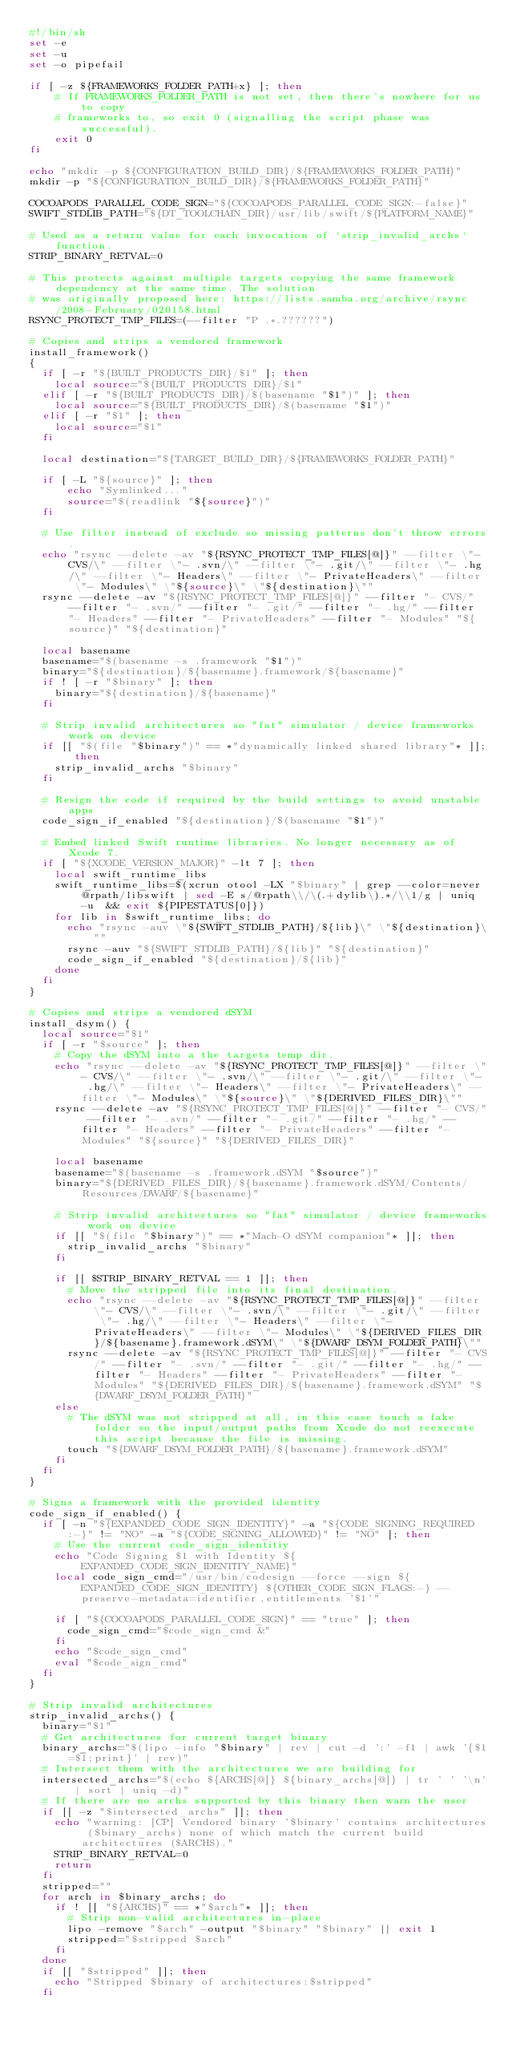<code> <loc_0><loc_0><loc_500><loc_500><_Bash_>#!/bin/sh
set -e
set -u
set -o pipefail

if [ -z ${FRAMEWORKS_FOLDER_PATH+x} ]; then
    # If FRAMEWORKS_FOLDER_PATH is not set, then there's nowhere for us to copy
    # frameworks to, so exit 0 (signalling the script phase was successful).
    exit 0
fi

echo "mkdir -p ${CONFIGURATION_BUILD_DIR}/${FRAMEWORKS_FOLDER_PATH}"
mkdir -p "${CONFIGURATION_BUILD_DIR}/${FRAMEWORKS_FOLDER_PATH}"

COCOAPODS_PARALLEL_CODE_SIGN="${COCOAPODS_PARALLEL_CODE_SIGN:-false}"
SWIFT_STDLIB_PATH="${DT_TOOLCHAIN_DIR}/usr/lib/swift/${PLATFORM_NAME}"

# Used as a return value for each invocation of `strip_invalid_archs` function.
STRIP_BINARY_RETVAL=0

# This protects against multiple targets copying the same framework dependency at the same time. The solution
# was originally proposed here: https://lists.samba.org/archive/rsync/2008-February/020158.html
RSYNC_PROTECT_TMP_FILES=(--filter "P .*.??????")

# Copies and strips a vendored framework
install_framework()
{
  if [ -r "${BUILT_PRODUCTS_DIR}/$1" ]; then
    local source="${BUILT_PRODUCTS_DIR}/$1"
  elif [ -r "${BUILT_PRODUCTS_DIR}/$(basename "$1")" ]; then
    local source="${BUILT_PRODUCTS_DIR}/$(basename "$1")"
  elif [ -r "$1" ]; then
    local source="$1"
  fi

  local destination="${TARGET_BUILD_DIR}/${FRAMEWORKS_FOLDER_PATH}"

  if [ -L "${source}" ]; then
      echo "Symlinked..."
      source="$(readlink "${source}")"
  fi

  # Use filter instead of exclude so missing patterns don't throw errors.
  echo "rsync --delete -av "${RSYNC_PROTECT_TMP_FILES[@]}" --filter \"- CVS/\" --filter \"- .svn/\" --filter \"- .git/\" --filter \"- .hg/\" --filter \"- Headers\" --filter \"- PrivateHeaders\" --filter \"- Modules\" \"${source}\" \"${destination}\""
  rsync --delete -av "${RSYNC_PROTECT_TMP_FILES[@]}" --filter "- CVS/" --filter "- .svn/" --filter "- .git/" --filter "- .hg/" --filter "- Headers" --filter "- PrivateHeaders" --filter "- Modules" "${source}" "${destination}"

  local basename
  basename="$(basename -s .framework "$1")"
  binary="${destination}/${basename}.framework/${basename}"
  if ! [ -r "$binary" ]; then
    binary="${destination}/${basename}"
  fi

  # Strip invalid architectures so "fat" simulator / device frameworks work on device
  if [[ "$(file "$binary")" == *"dynamically linked shared library"* ]]; then
    strip_invalid_archs "$binary"
  fi

  # Resign the code if required by the build settings to avoid unstable apps
  code_sign_if_enabled "${destination}/$(basename "$1")"

  # Embed linked Swift runtime libraries. No longer necessary as of Xcode 7.
  if [ "${XCODE_VERSION_MAJOR}" -lt 7 ]; then
    local swift_runtime_libs
    swift_runtime_libs=$(xcrun otool -LX "$binary" | grep --color=never @rpath/libswift | sed -E s/@rpath\\/\(.+dylib\).*/\\1/g | uniq -u  && exit ${PIPESTATUS[0]})
    for lib in $swift_runtime_libs; do
      echo "rsync -auv \"${SWIFT_STDLIB_PATH}/${lib}\" \"${destination}\""
      rsync -auv "${SWIFT_STDLIB_PATH}/${lib}" "${destination}"
      code_sign_if_enabled "${destination}/${lib}"
    done
  fi
}

# Copies and strips a vendored dSYM
install_dsym() {
  local source="$1"
  if [ -r "$source" ]; then
    # Copy the dSYM into a the targets temp dir.
    echo "rsync --delete -av "${RSYNC_PROTECT_TMP_FILES[@]}" --filter \"- CVS/\" --filter \"- .svn/\" --filter \"- .git/\" --filter \"- .hg/\" --filter \"- Headers\" --filter \"- PrivateHeaders\" --filter \"- Modules\" \"${source}\" \"${DERIVED_FILES_DIR}\""
    rsync --delete -av "${RSYNC_PROTECT_TMP_FILES[@]}" --filter "- CVS/" --filter "- .svn/" --filter "- .git/" --filter "- .hg/" --filter "- Headers" --filter "- PrivateHeaders" --filter "- Modules" "${source}" "${DERIVED_FILES_DIR}"

    local basename
    basename="$(basename -s .framework.dSYM "$source")"
    binary="${DERIVED_FILES_DIR}/${basename}.framework.dSYM/Contents/Resources/DWARF/${basename}"

    # Strip invalid architectures so "fat" simulator / device frameworks work on device
    if [[ "$(file "$binary")" == *"Mach-O dSYM companion"* ]]; then
      strip_invalid_archs "$binary"
    fi

    if [[ $STRIP_BINARY_RETVAL == 1 ]]; then
      # Move the stripped file into its final destination.
      echo "rsync --delete -av "${RSYNC_PROTECT_TMP_FILES[@]}" --filter \"- CVS/\" --filter \"- .svn/\" --filter \"- .git/\" --filter \"- .hg/\" --filter \"- Headers\" --filter \"- PrivateHeaders\" --filter \"- Modules\" \"${DERIVED_FILES_DIR}/${basename}.framework.dSYM\" \"${DWARF_DSYM_FOLDER_PATH}\""
      rsync --delete -av "${RSYNC_PROTECT_TMP_FILES[@]}" --filter "- CVS/" --filter "- .svn/" --filter "- .git/" --filter "- .hg/" --filter "- Headers" --filter "- PrivateHeaders" --filter "- Modules" "${DERIVED_FILES_DIR}/${basename}.framework.dSYM" "${DWARF_DSYM_FOLDER_PATH}"
    else
      # The dSYM was not stripped at all, in this case touch a fake folder so the input/output paths from Xcode do not reexecute this script because the file is missing.
      touch "${DWARF_DSYM_FOLDER_PATH}/${basename}.framework.dSYM"
    fi
  fi
}

# Signs a framework with the provided identity
code_sign_if_enabled() {
  if [ -n "${EXPANDED_CODE_SIGN_IDENTITY}" -a "${CODE_SIGNING_REQUIRED:-}" != "NO" -a "${CODE_SIGNING_ALLOWED}" != "NO" ]; then
    # Use the current code_sign_identitiy
    echo "Code Signing $1 with Identity ${EXPANDED_CODE_SIGN_IDENTITY_NAME}"
    local code_sign_cmd="/usr/bin/codesign --force --sign ${EXPANDED_CODE_SIGN_IDENTITY} ${OTHER_CODE_SIGN_FLAGS:-} --preserve-metadata=identifier,entitlements '$1'"

    if [ "${COCOAPODS_PARALLEL_CODE_SIGN}" == "true" ]; then
      code_sign_cmd="$code_sign_cmd &"
    fi
    echo "$code_sign_cmd"
    eval "$code_sign_cmd"
  fi
}

# Strip invalid architectures
strip_invalid_archs() {
  binary="$1"
  # Get architectures for current target binary
  binary_archs="$(lipo -info "$binary" | rev | cut -d ':' -f1 | awk '{$1=$1;print}' | rev)"
  # Intersect them with the architectures we are building for
  intersected_archs="$(echo ${ARCHS[@]} ${binary_archs[@]} | tr ' ' '\n' | sort | uniq -d)"
  # If there are no archs supported by this binary then warn the user
  if [[ -z "$intersected_archs" ]]; then
    echo "warning: [CP] Vendored binary '$binary' contains architectures ($binary_archs) none of which match the current build architectures ($ARCHS)."
    STRIP_BINARY_RETVAL=0
    return
  fi
  stripped=""
  for arch in $binary_archs; do
    if ! [[ "${ARCHS}" == *"$arch"* ]]; then
      # Strip non-valid architectures in-place
      lipo -remove "$arch" -output "$binary" "$binary" || exit 1
      stripped="$stripped $arch"
    fi
  done
  if [[ "$stripped" ]]; then
    echo "Stripped $binary of architectures:$stripped"
  fi</code> 